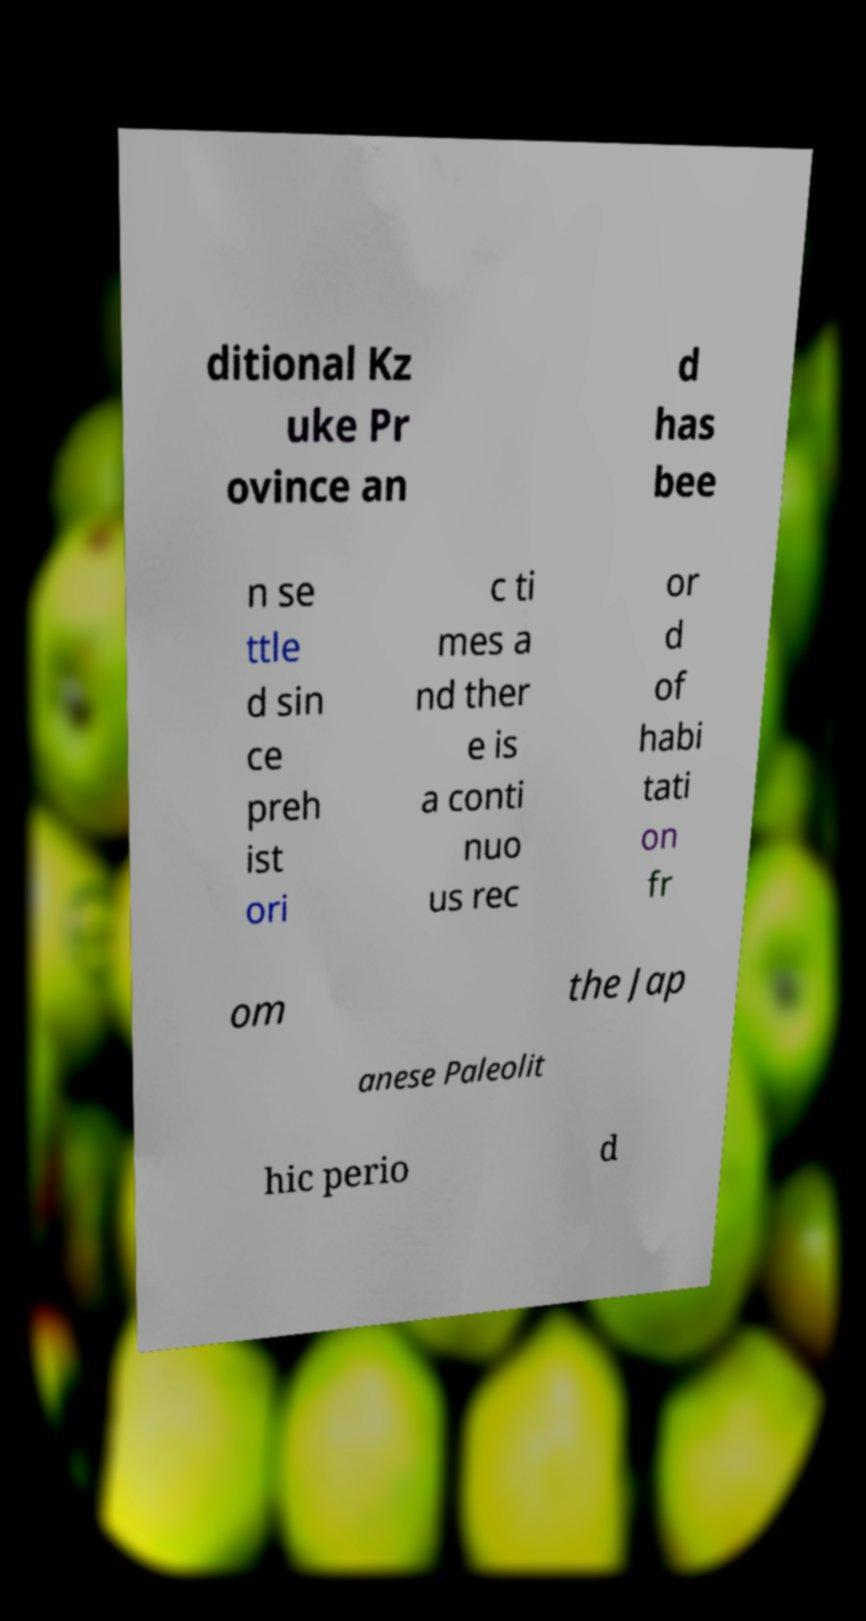Can you accurately transcribe the text from the provided image for me? ditional Kz uke Pr ovince an d has bee n se ttle d sin ce preh ist ori c ti mes a nd ther e is a conti nuo us rec or d of habi tati on fr om the Jap anese Paleolit hic perio d 